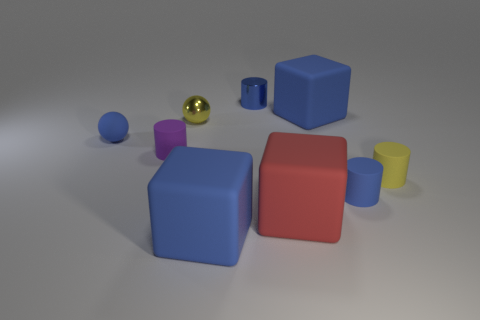Subtract all cubes. How many objects are left? 6 Subtract all big cyan matte cylinders. Subtract all tiny purple rubber things. How many objects are left? 8 Add 3 small rubber objects. How many small rubber objects are left? 7 Add 5 blocks. How many blocks exist? 8 Subtract 1 yellow balls. How many objects are left? 8 